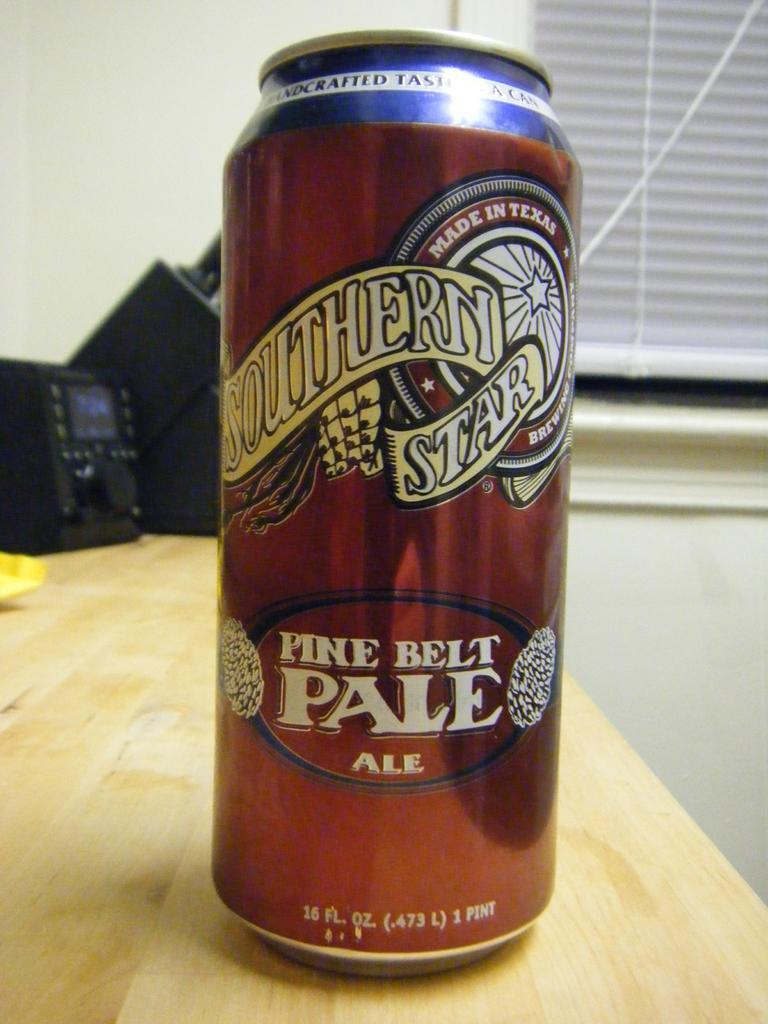<image>
Summarize the visual content of the image. A can of Southern Star pale ale sits on a wooden table. 